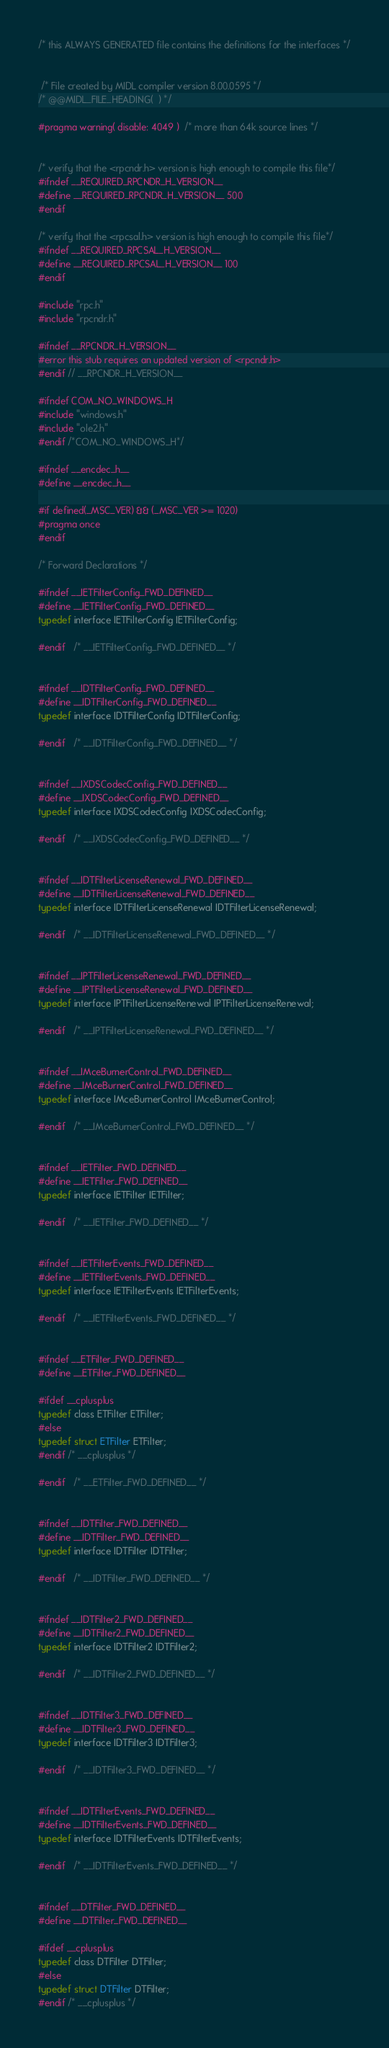<code> <loc_0><loc_0><loc_500><loc_500><_C_>

/* this ALWAYS GENERATED file contains the definitions for the interfaces */


 /* File created by MIDL compiler version 8.00.0595 */
/* @@MIDL_FILE_HEADING(  ) */

#pragma warning( disable: 4049 )  /* more than 64k source lines */


/* verify that the <rpcndr.h> version is high enough to compile this file*/
#ifndef __REQUIRED_RPCNDR_H_VERSION__
#define __REQUIRED_RPCNDR_H_VERSION__ 500
#endif

/* verify that the <rpcsal.h> version is high enough to compile this file*/
#ifndef __REQUIRED_RPCSAL_H_VERSION__
#define __REQUIRED_RPCSAL_H_VERSION__ 100
#endif

#include "rpc.h"
#include "rpcndr.h"

#ifndef __RPCNDR_H_VERSION__
#error this stub requires an updated version of <rpcndr.h>
#endif // __RPCNDR_H_VERSION__

#ifndef COM_NO_WINDOWS_H
#include "windows.h"
#include "ole2.h"
#endif /*COM_NO_WINDOWS_H*/

#ifndef __encdec_h__
#define __encdec_h__

#if defined(_MSC_VER) && (_MSC_VER >= 1020)
#pragma once
#endif

/* Forward Declarations */ 

#ifndef __IETFilterConfig_FWD_DEFINED__
#define __IETFilterConfig_FWD_DEFINED__
typedef interface IETFilterConfig IETFilterConfig;

#endif 	/* __IETFilterConfig_FWD_DEFINED__ */


#ifndef __IDTFilterConfig_FWD_DEFINED__
#define __IDTFilterConfig_FWD_DEFINED__
typedef interface IDTFilterConfig IDTFilterConfig;

#endif 	/* __IDTFilterConfig_FWD_DEFINED__ */


#ifndef __IXDSCodecConfig_FWD_DEFINED__
#define __IXDSCodecConfig_FWD_DEFINED__
typedef interface IXDSCodecConfig IXDSCodecConfig;

#endif 	/* __IXDSCodecConfig_FWD_DEFINED__ */


#ifndef __IDTFilterLicenseRenewal_FWD_DEFINED__
#define __IDTFilterLicenseRenewal_FWD_DEFINED__
typedef interface IDTFilterLicenseRenewal IDTFilterLicenseRenewal;

#endif 	/* __IDTFilterLicenseRenewal_FWD_DEFINED__ */


#ifndef __IPTFilterLicenseRenewal_FWD_DEFINED__
#define __IPTFilterLicenseRenewal_FWD_DEFINED__
typedef interface IPTFilterLicenseRenewal IPTFilterLicenseRenewal;

#endif 	/* __IPTFilterLicenseRenewal_FWD_DEFINED__ */


#ifndef __IMceBurnerControl_FWD_DEFINED__
#define __IMceBurnerControl_FWD_DEFINED__
typedef interface IMceBurnerControl IMceBurnerControl;

#endif 	/* __IMceBurnerControl_FWD_DEFINED__ */


#ifndef __IETFilter_FWD_DEFINED__
#define __IETFilter_FWD_DEFINED__
typedef interface IETFilter IETFilter;

#endif 	/* __IETFilter_FWD_DEFINED__ */


#ifndef __IETFilterEvents_FWD_DEFINED__
#define __IETFilterEvents_FWD_DEFINED__
typedef interface IETFilterEvents IETFilterEvents;

#endif 	/* __IETFilterEvents_FWD_DEFINED__ */


#ifndef __ETFilter_FWD_DEFINED__
#define __ETFilter_FWD_DEFINED__

#ifdef __cplusplus
typedef class ETFilter ETFilter;
#else
typedef struct ETFilter ETFilter;
#endif /* __cplusplus */

#endif 	/* __ETFilter_FWD_DEFINED__ */


#ifndef __IDTFilter_FWD_DEFINED__
#define __IDTFilter_FWD_DEFINED__
typedef interface IDTFilter IDTFilter;

#endif 	/* __IDTFilter_FWD_DEFINED__ */


#ifndef __IDTFilter2_FWD_DEFINED__
#define __IDTFilter2_FWD_DEFINED__
typedef interface IDTFilter2 IDTFilter2;

#endif 	/* __IDTFilter2_FWD_DEFINED__ */


#ifndef __IDTFilter3_FWD_DEFINED__
#define __IDTFilter3_FWD_DEFINED__
typedef interface IDTFilter3 IDTFilter3;

#endif 	/* __IDTFilter3_FWD_DEFINED__ */


#ifndef __IDTFilterEvents_FWD_DEFINED__
#define __IDTFilterEvents_FWD_DEFINED__
typedef interface IDTFilterEvents IDTFilterEvents;

#endif 	/* __IDTFilterEvents_FWD_DEFINED__ */


#ifndef __DTFilter_FWD_DEFINED__
#define __DTFilter_FWD_DEFINED__

#ifdef __cplusplus
typedef class DTFilter DTFilter;
#else
typedef struct DTFilter DTFilter;
#endif /* __cplusplus */
</code> 